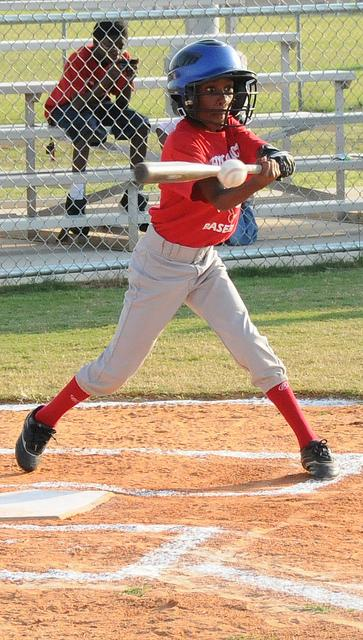What team wears similar socks to the boy in the foreground?

Choices:
A) mets
B) jets
C) red sox
D) white sox red sox 